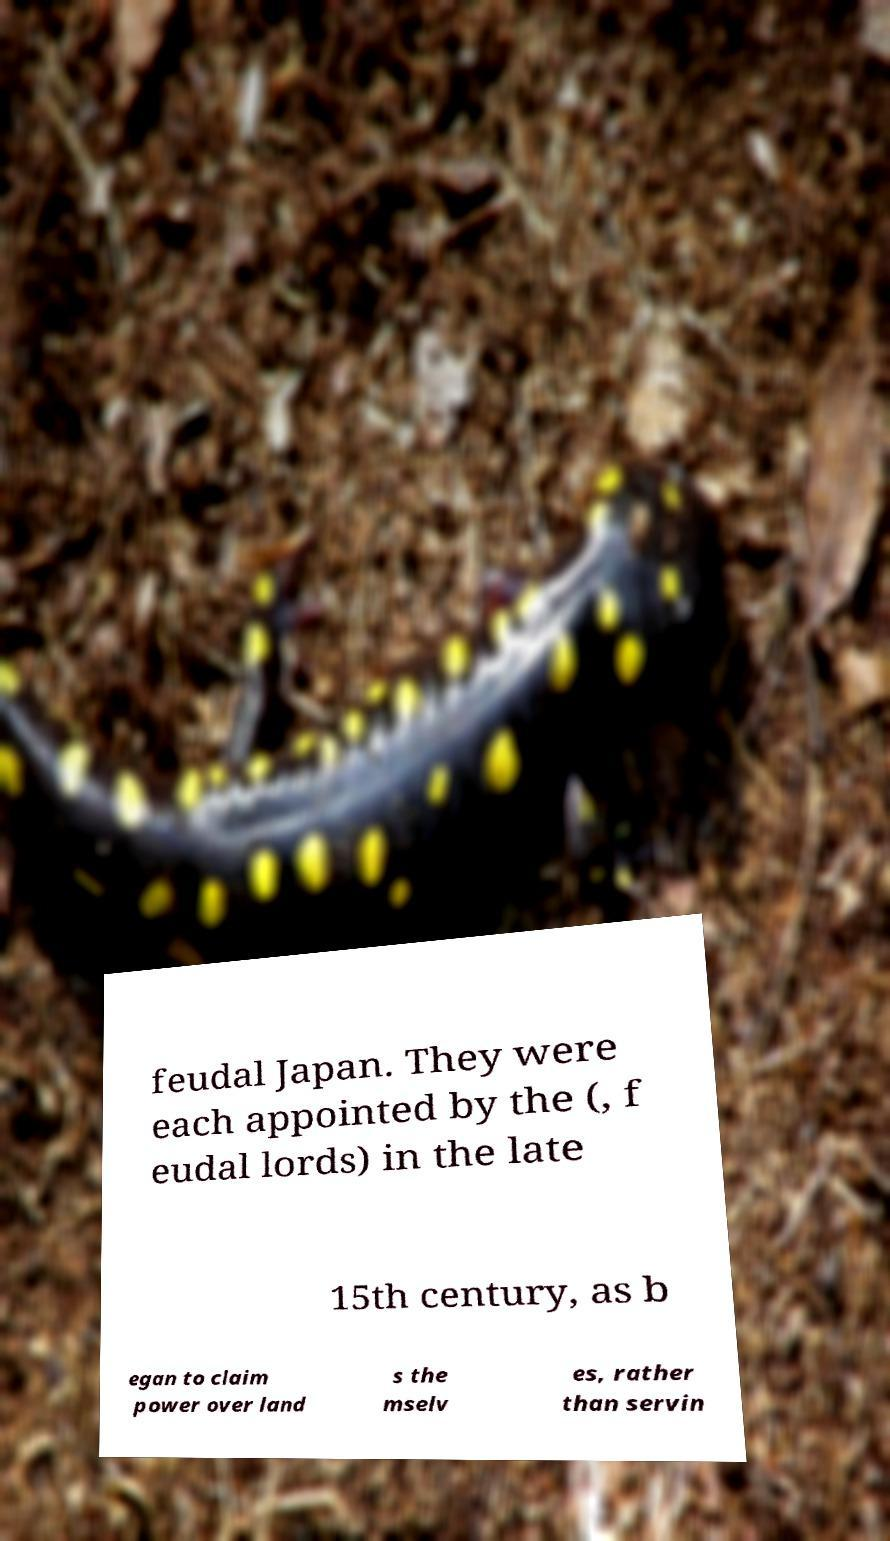For documentation purposes, I need the text within this image transcribed. Could you provide that? feudal Japan. They were each appointed by the (, f eudal lords) in the late 15th century, as b egan to claim power over land s the mselv es, rather than servin 